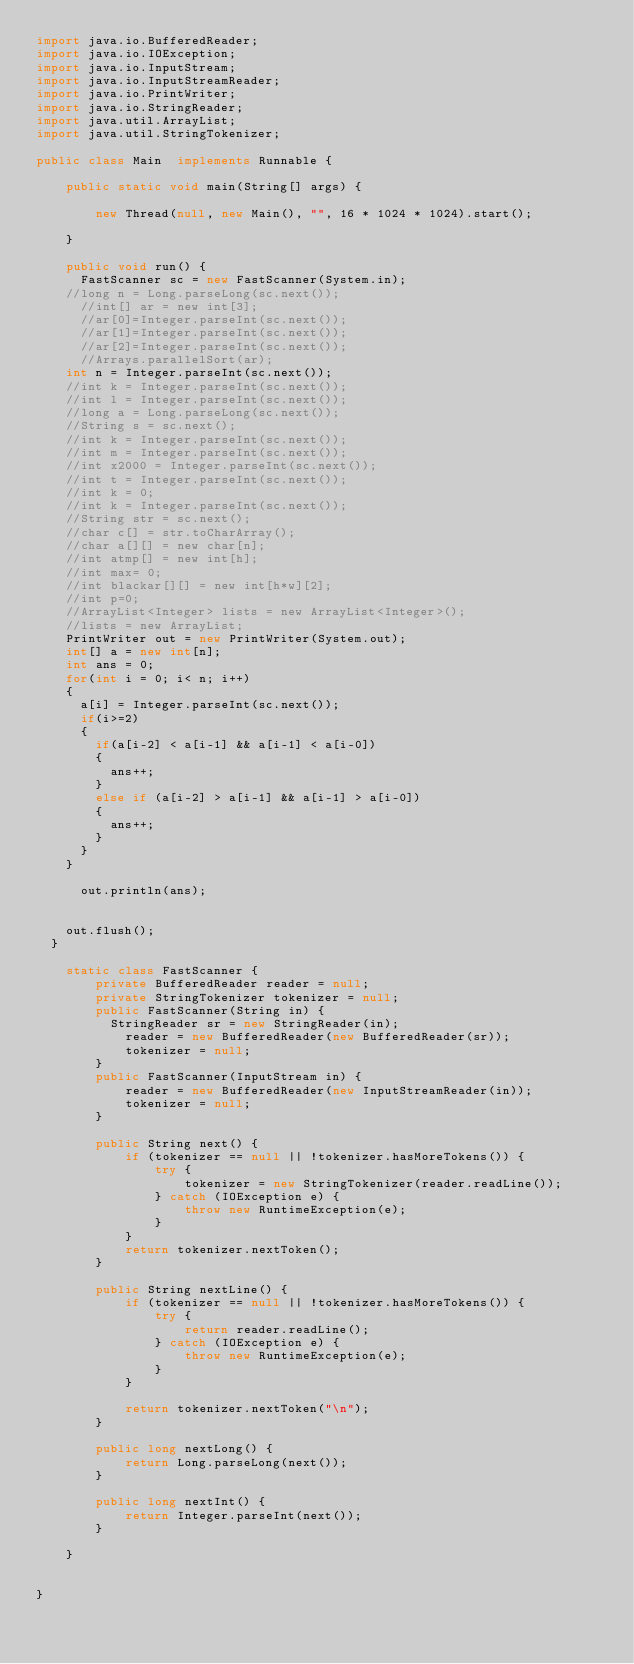Convert code to text. <code><loc_0><loc_0><loc_500><loc_500><_Java_>import java.io.BufferedReader;
import java.io.IOException;
import java.io.InputStream;
import java.io.InputStreamReader;
import java.io.PrintWriter;
import java.io.StringReader;
import java.util.ArrayList;
import java.util.StringTokenizer;

public class Main  implements Runnable {

    public static void main(String[] args) {

        new Thread(null, new Main(), "", 16 * 1024 * 1024).start();

    }

    public void run() {
    	FastScanner sc = new FastScanner(System.in);
		//long n = Long.parseLong(sc.next());
    	//int[] ar = new int[3];
    	//ar[0]=Integer.parseInt(sc.next());
    	//ar[1]=Integer.parseInt(sc.next());
    	//ar[2]=Integer.parseInt(sc.next());
    	//Arrays.parallelSort(ar);
		int n = Integer.parseInt(sc.next());
		//int k = Integer.parseInt(sc.next());
		//int l = Integer.parseInt(sc.next());
		//long a = Long.parseLong(sc.next());
		//String s = sc.next();
		//int k = Integer.parseInt(sc.next());
		//int m = Integer.parseInt(sc.next());
		//int x2000 = Integer.parseInt(sc.next());
		//int t = Integer.parseInt(sc.next());
		//int k = 0;
		//int k = Integer.parseInt(sc.next());
		//String str = sc.next();
		//char c[] = str.toCharArray();
		//char a[][] = new char[n];
		//int atmp[] = new int[h];
		//int max= 0;
		//int blackar[][] = new int[h*w][2];
		//int p=0;
		//ArrayList<Integer> lists = new ArrayList<Integer>();
		//lists = new ArrayList;
		PrintWriter out = new PrintWriter(System.out);
		int[] a = new int[n];
		int ans = 0;
		for(int i = 0; i< n; i++)
		{
			a[i] = Integer.parseInt(sc.next());
			if(i>=2)
			{
				if(a[i-2] < a[i-1] && a[i-1] < a[i-0])
				{
					ans++;
				}
				else if (a[i-2] > a[i-1] && a[i-1] > a[i-0])
				{
					ans++;
				}
			}
		}

			out.println(ans);


		out.flush();
	}

    static class FastScanner {
        private BufferedReader reader = null;
        private StringTokenizer tokenizer = null;
        public FastScanner(String in) {
        	StringReader sr = new StringReader(in);
            reader = new BufferedReader(new BufferedReader(sr));
            tokenizer = null;
        }
        public FastScanner(InputStream in) {
            reader = new BufferedReader(new InputStreamReader(in));
            tokenizer = null;
        }

        public String next() {
            if (tokenizer == null || !tokenizer.hasMoreTokens()) {
                try {
                    tokenizer = new StringTokenizer(reader.readLine());
                } catch (IOException e) {
                    throw new RuntimeException(e);
                }
            }
            return tokenizer.nextToken();
        }

        public String nextLine() {
            if (tokenizer == null || !tokenizer.hasMoreTokens()) {
                try {
                    return reader.readLine();
                } catch (IOException e) {
                    throw new RuntimeException(e);
                }
            }

            return tokenizer.nextToken("\n");
        }

        public long nextLong() {
            return Long.parseLong(next());
        }

        public long nextInt() {
            return Integer.parseInt(next());
        }

    }


}
</code> 